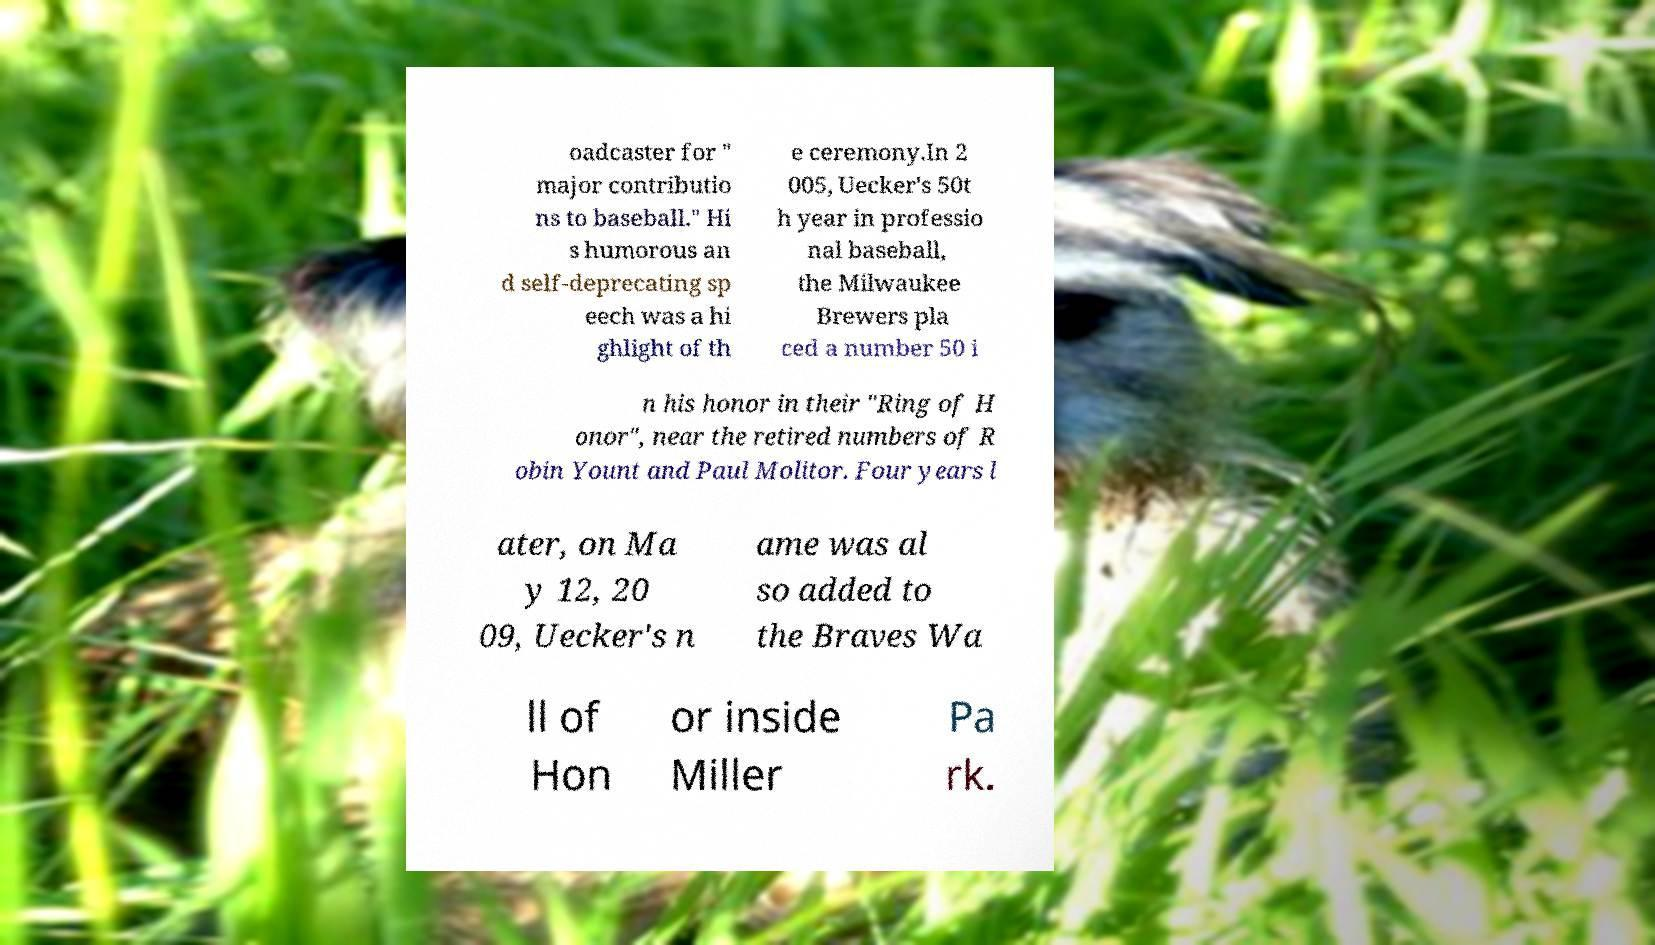What messages or text are displayed in this image? I need them in a readable, typed format. oadcaster for " major contributio ns to baseball." Hi s humorous an d self-deprecating sp eech was a hi ghlight of th e ceremony.In 2 005, Uecker's 50t h year in professio nal baseball, the Milwaukee Brewers pla ced a number 50 i n his honor in their "Ring of H onor", near the retired numbers of R obin Yount and Paul Molitor. Four years l ater, on Ma y 12, 20 09, Uecker's n ame was al so added to the Braves Wa ll of Hon or inside Miller Pa rk. 